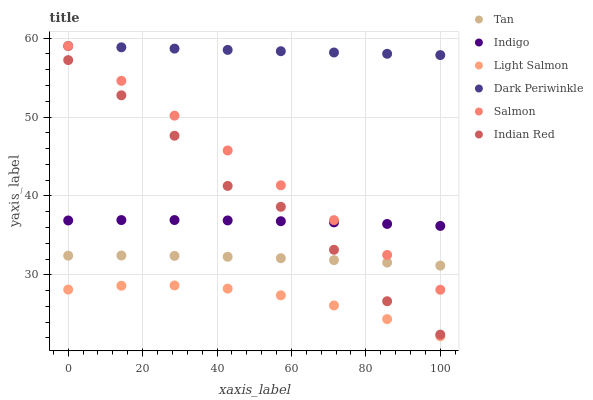Does Light Salmon have the minimum area under the curve?
Answer yes or no. Yes. Does Dark Periwinkle have the maximum area under the curve?
Answer yes or no. Yes. Does Indigo have the minimum area under the curve?
Answer yes or no. No. Does Indigo have the maximum area under the curve?
Answer yes or no. No. Is Salmon the smoothest?
Answer yes or no. Yes. Is Indian Red the roughest?
Answer yes or no. Yes. Is Indigo the smoothest?
Answer yes or no. No. Is Indigo the roughest?
Answer yes or no. No. Does Light Salmon have the lowest value?
Answer yes or no. Yes. Does Indigo have the lowest value?
Answer yes or no. No. Does Dark Periwinkle have the highest value?
Answer yes or no. Yes. Does Indigo have the highest value?
Answer yes or no. No. Is Light Salmon less than Indian Red?
Answer yes or no. Yes. Is Indigo greater than Tan?
Answer yes or no. Yes. Does Salmon intersect Indigo?
Answer yes or no. Yes. Is Salmon less than Indigo?
Answer yes or no. No. Is Salmon greater than Indigo?
Answer yes or no. No. Does Light Salmon intersect Indian Red?
Answer yes or no. No. 